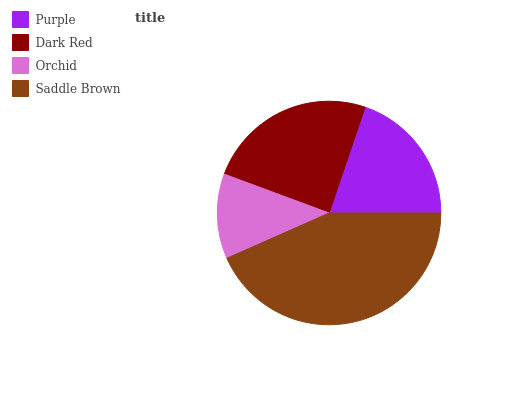Is Orchid the minimum?
Answer yes or no. Yes. Is Saddle Brown the maximum?
Answer yes or no. Yes. Is Dark Red the minimum?
Answer yes or no. No. Is Dark Red the maximum?
Answer yes or no. No. Is Dark Red greater than Purple?
Answer yes or no. Yes. Is Purple less than Dark Red?
Answer yes or no. Yes. Is Purple greater than Dark Red?
Answer yes or no. No. Is Dark Red less than Purple?
Answer yes or no. No. Is Dark Red the high median?
Answer yes or no. Yes. Is Purple the low median?
Answer yes or no. Yes. Is Saddle Brown the high median?
Answer yes or no. No. Is Dark Red the low median?
Answer yes or no. No. 